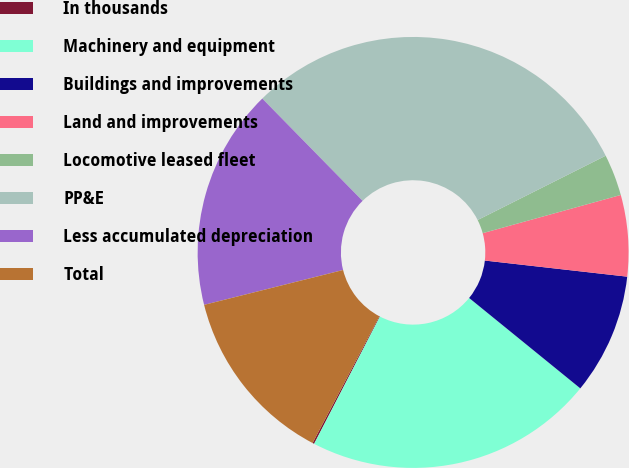Convert chart. <chart><loc_0><loc_0><loc_500><loc_500><pie_chart><fcel>In thousands<fcel>Machinery and equipment<fcel>Buildings and improvements<fcel>Land and improvements<fcel>Locomotive leased fleet<fcel>PP&E<fcel>Less accumulated depreciation<fcel>Total<nl><fcel>0.13%<fcel>21.73%<fcel>9.07%<fcel>6.09%<fcel>3.11%<fcel>29.93%<fcel>16.57%<fcel>13.36%<nl></chart> 